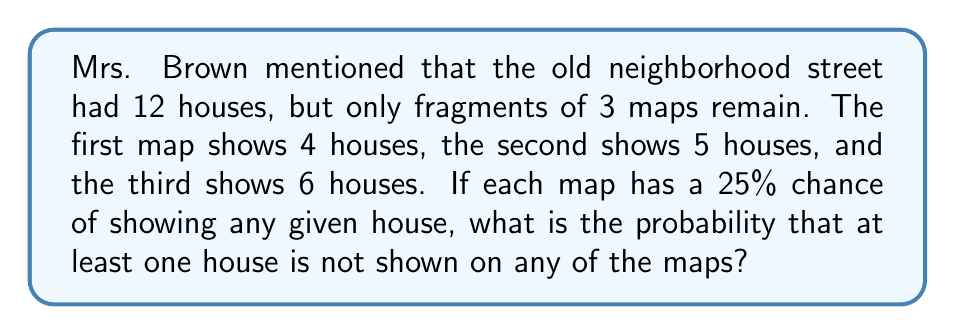Show me your answer to this math problem. Let's approach this step-by-step:

1) First, let's calculate the probability that a specific house is not shown on any of the maps:
   Probability of not being on a single map = 75% = 0.75
   Probability of not being on all three maps = $0.75^3 = 0.421875$

2) Now, the probability that a specific house is shown on at least one map:
   $1 - 0.421875 = 0.578125$

3) For all houses to be shown on at least one map, each house must be shown. The probability of this:
   $0.578125^{12} = 0.0000354$

4) Therefore, the probability that at least one house is not shown on any map:
   $1 - 0.0000354 = 0.9999646$

5) To convert to a percentage:
   $0.9999646 * 100 = 99.99646\%$

This extremely high probability suggests that it's almost certain that at least one house is missing from all the maps, which aligns with the difficulty of reconstructing old neighborhood layouts from fragmented information.
Answer: 99.99646% 